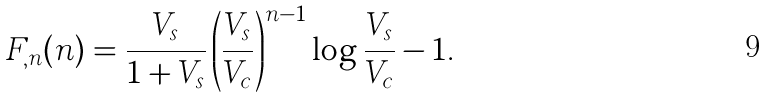Convert formula to latex. <formula><loc_0><loc_0><loc_500><loc_500>F _ { , n } ( n ) = \frac { V _ { s } } { 1 + V _ { s } } \left ( \frac { V _ { s } } { V _ { c } } \right ) ^ { n - 1 } \log \frac { V _ { s } } { V _ { c } } - 1 .</formula> 